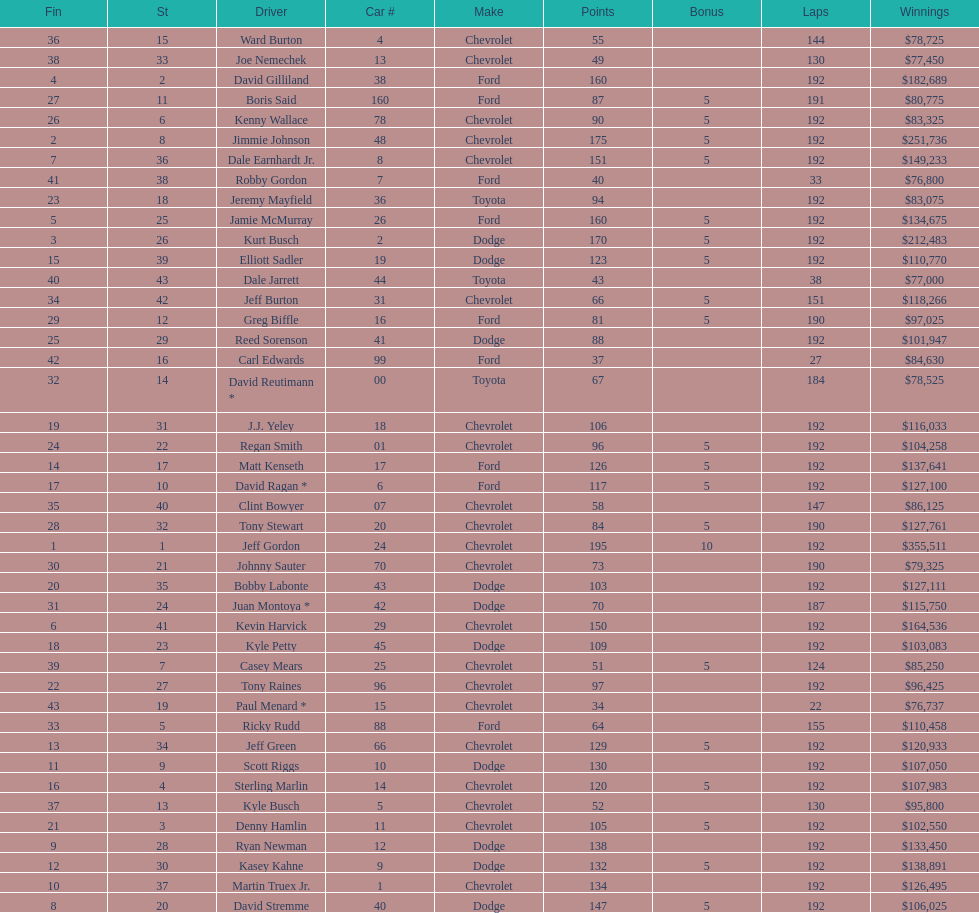What make did kurt busch drive? Dodge. 